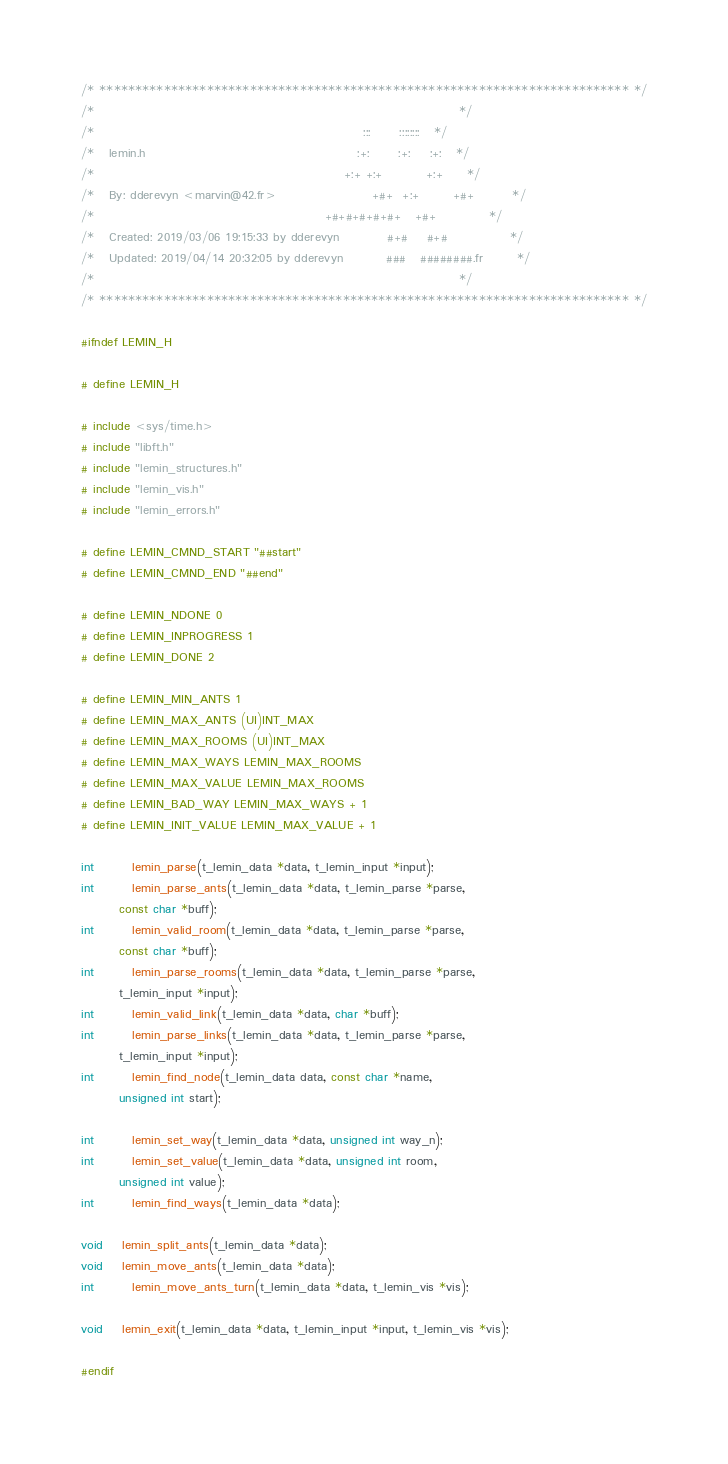Convert code to text. <code><loc_0><loc_0><loc_500><loc_500><_C_>/* ************************************************************************** */
/*                                                                            */
/*                                                        :::      ::::::::   */
/*   lemin.h                                            :+:      :+:    :+:   */
/*                                                    +:+ +:+         +:+     */
/*   By: dderevyn <marvin@42.fr>                    +#+  +:+       +#+        */
/*                                                +#+#+#+#+#+   +#+           */
/*   Created: 2019/03/06 19:15:33 by dderevyn          #+#    #+#             */
/*   Updated: 2019/04/14 20:32:05 by dderevyn         ###   ########.fr       */
/*                                                                            */
/* ************************************************************************** */

#ifndef LEMIN_H

# define LEMIN_H

# include <sys/time.h>
# include "libft.h"
# include "lemin_structures.h"
# include "lemin_vis.h"
# include "lemin_errors.h"

# define LEMIN_CMND_START "##start"
# define LEMIN_CMND_END "##end"

# define LEMIN_NDONE 0
# define LEMIN_INPROGRESS 1
# define LEMIN_DONE 2

# define LEMIN_MIN_ANTS 1
# define LEMIN_MAX_ANTS (UI)INT_MAX
# define LEMIN_MAX_ROOMS (UI)INT_MAX
# define LEMIN_MAX_WAYS LEMIN_MAX_ROOMS
# define LEMIN_MAX_VALUE LEMIN_MAX_ROOMS
# define LEMIN_BAD_WAY LEMIN_MAX_WAYS + 1
# define LEMIN_INIT_VALUE LEMIN_MAX_VALUE + 1

int		lemin_parse(t_lemin_data *data, t_lemin_input *input);
int		lemin_parse_ants(t_lemin_data *data, t_lemin_parse *parse,
		const char *buff);
int		lemin_valid_room(t_lemin_data *data, t_lemin_parse *parse,
		const char *buff);
int		lemin_parse_rooms(t_lemin_data *data, t_lemin_parse *parse,
		t_lemin_input *input);
int		lemin_valid_link(t_lemin_data *data, char *buff);
int		lemin_parse_links(t_lemin_data *data, t_lemin_parse *parse,
		t_lemin_input *input);
int		lemin_find_node(t_lemin_data data, const char *name,
		unsigned int start);

int		lemin_set_way(t_lemin_data *data, unsigned int way_n);
int		lemin_set_value(t_lemin_data *data, unsigned int room,
		unsigned int value);
int		lemin_find_ways(t_lemin_data *data);

void	lemin_split_ants(t_lemin_data *data);
void	lemin_move_ants(t_lemin_data *data);
int		lemin_move_ants_turn(t_lemin_data *data, t_lemin_vis *vis);

void	lemin_exit(t_lemin_data *data, t_lemin_input *input, t_lemin_vis *vis);

#endif
</code> 